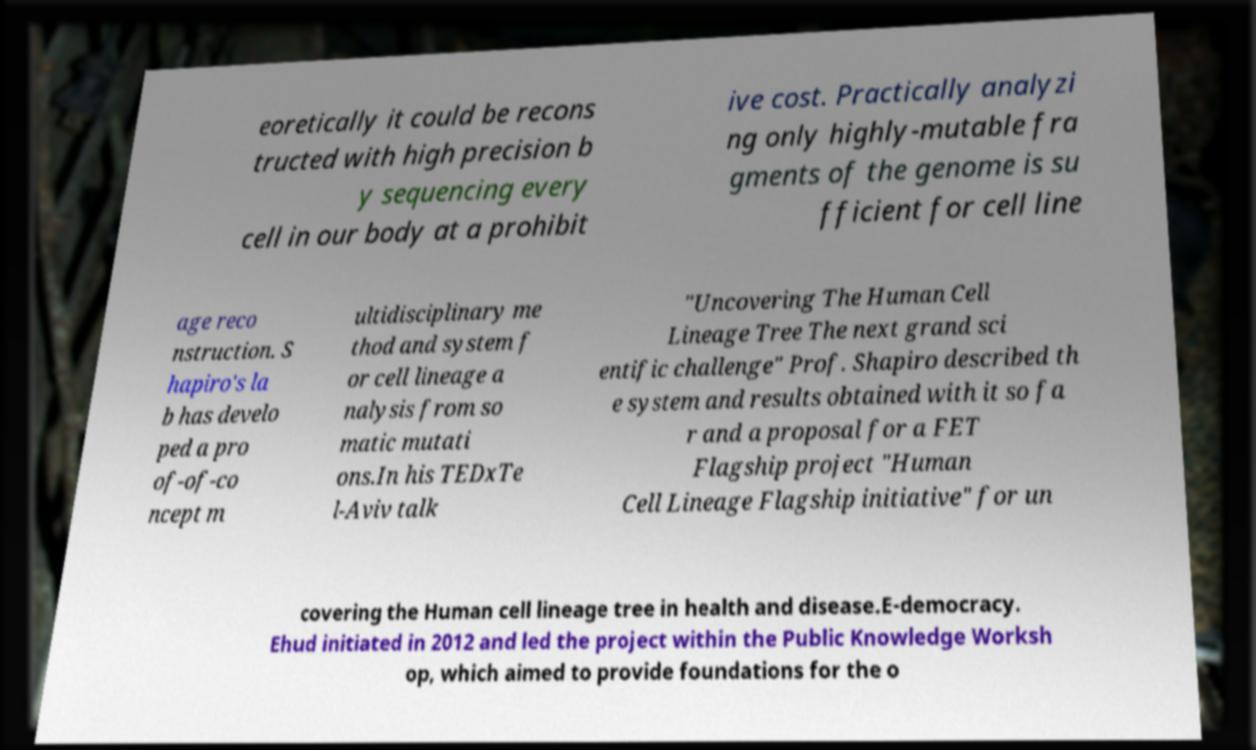Could you extract and type out the text from this image? eoretically it could be recons tructed with high precision b y sequencing every cell in our body at a prohibit ive cost. Practically analyzi ng only highly-mutable fra gments of the genome is su fficient for cell line age reco nstruction. S hapiro's la b has develo ped a pro of-of-co ncept m ultidisciplinary me thod and system f or cell lineage a nalysis from so matic mutati ons.In his TEDxTe l-Aviv talk "Uncovering The Human Cell Lineage Tree The next grand sci entific challenge" Prof. Shapiro described th e system and results obtained with it so fa r and a proposal for a FET Flagship project "Human Cell Lineage Flagship initiative" for un covering the Human cell lineage tree in health and disease.E-democracy. Ehud initiated in 2012 and led the project within the Public Knowledge Worksh op, which aimed to provide foundations for the o 